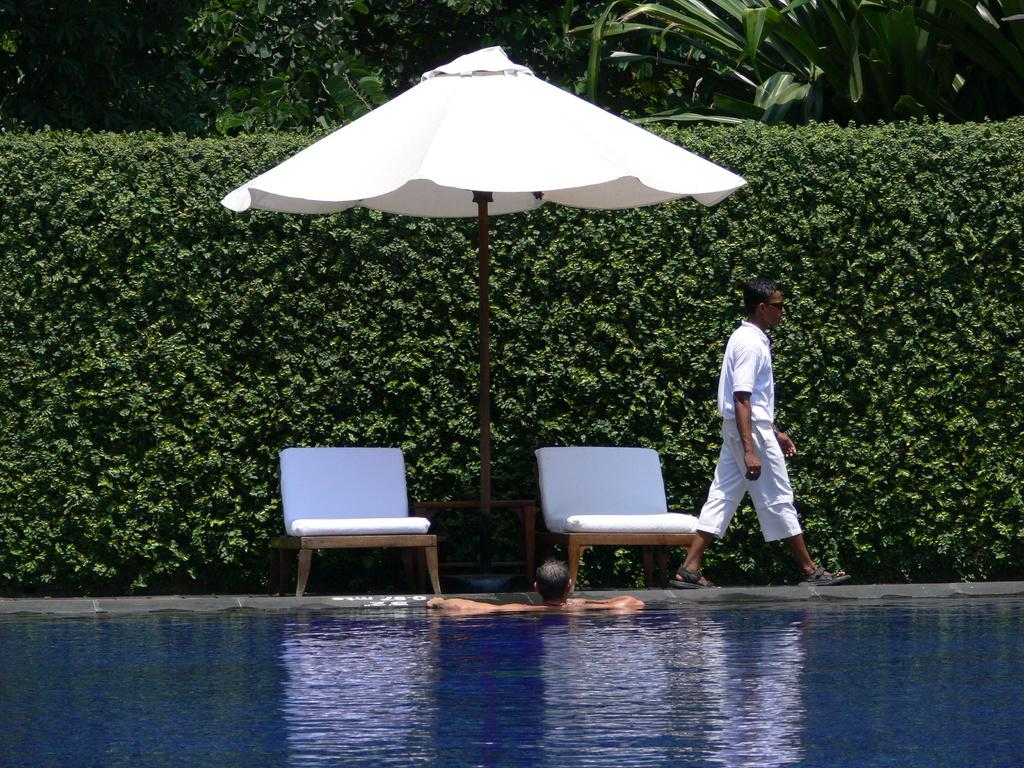What is the man doing in the image? The man is walking on a platform in the image. What is happening in the water near the platform? There is a person in the water near the platform. What can be seen in the background of the image? There are trees, plants, a tent, and two chairs in the background. What type of marble is being used to build the tent in the image? There is no marble present in the image, and the tent is not being built. How much money is the person in the water holding in the image? There is no indication of money in the image, and the person in the water is not holding any money. 